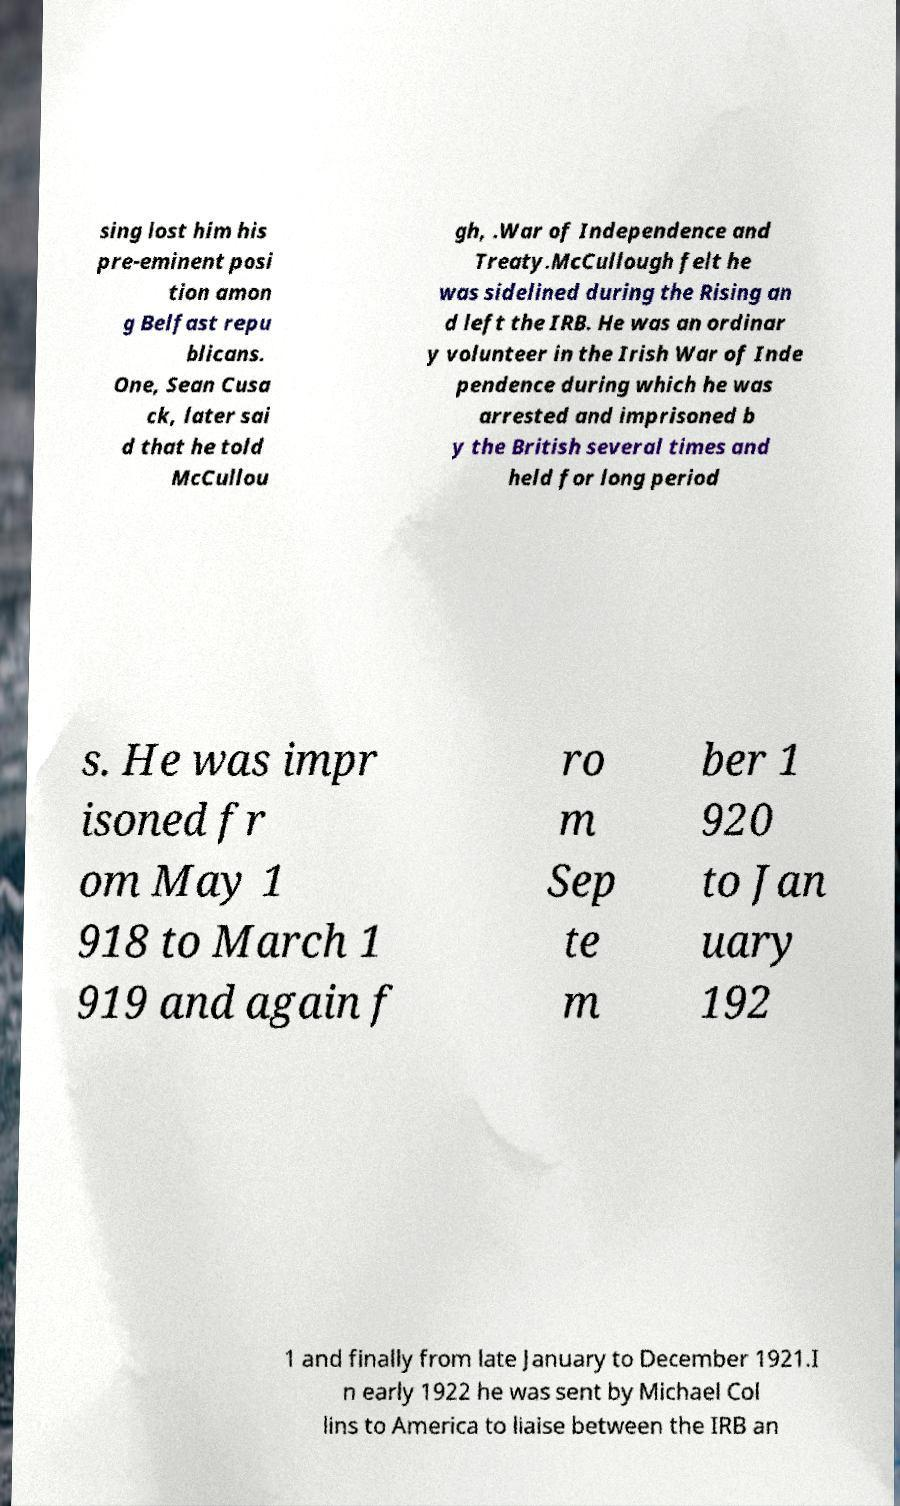For documentation purposes, I need the text within this image transcribed. Could you provide that? sing lost him his pre-eminent posi tion amon g Belfast repu blicans. One, Sean Cusa ck, later sai d that he told McCullou gh, .War of Independence and Treaty.McCullough felt he was sidelined during the Rising an d left the IRB. He was an ordinar y volunteer in the Irish War of Inde pendence during which he was arrested and imprisoned b y the British several times and held for long period s. He was impr isoned fr om May 1 918 to March 1 919 and again f ro m Sep te m ber 1 920 to Jan uary 192 1 and finally from late January to December 1921.I n early 1922 he was sent by Michael Col lins to America to liaise between the IRB an 